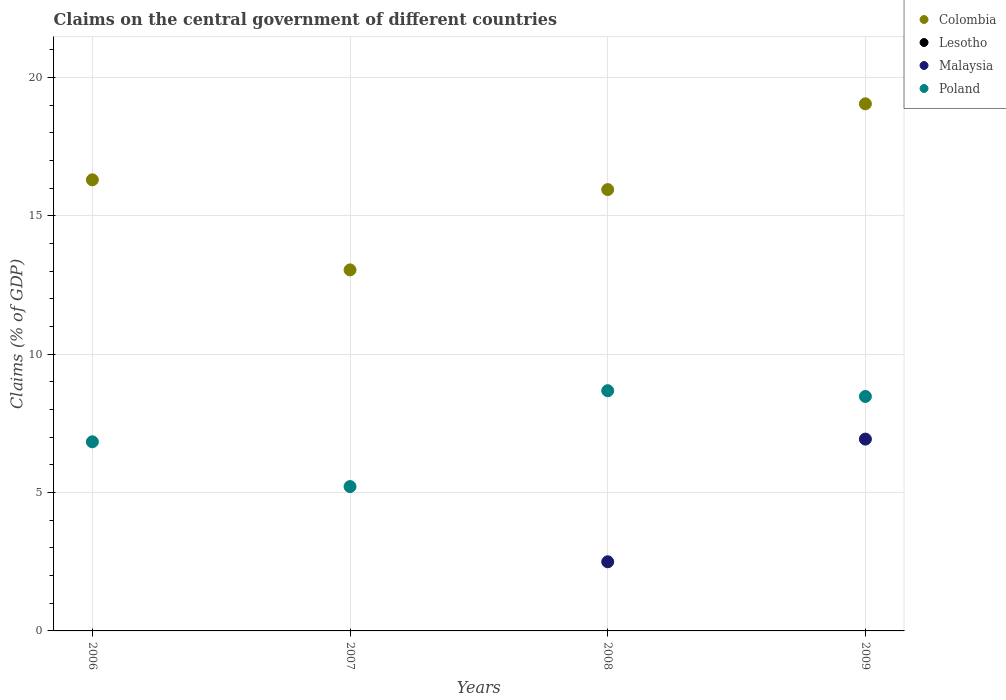What is the percentage of GDP claimed on the central government in Colombia in 2009?
Ensure brevity in your answer.  19.05. Across all years, what is the maximum percentage of GDP claimed on the central government in Poland?
Provide a succinct answer. 8.68. Across all years, what is the minimum percentage of GDP claimed on the central government in Colombia?
Give a very brief answer. 13.04. What is the total percentage of GDP claimed on the central government in Poland in the graph?
Make the answer very short. 29.2. What is the difference between the percentage of GDP claimed on the central government in Malaysia in 2008 and that in 2009?
Your response must be concise. -4.43. What is the difference between the percentage of GDP claimed on the central government in Lesotho in 2006 and the percentage of GDP claimed on the central government in Colombia in 2009?
Ensure brevity in your answer.  -19.05. What is the average percentage of GDP claimed on the central government in Poland per year?
Provide a succinct answer. 7.3. In the year 2008, what is the difference between the percentage of GDP claimed on the central government in Colombia and percentage of GDP claimed on the central government in Poland?
Keep it short and to the point. 7.27. What is the ratio of the percentage of GDP claimed on the central government in Poland in 2006 to that in 2009?
Offer a very short reply. 0.81. Is the percentage of GDP claimed on the central government in Colombia in 2007 less than that in 2009?
Your response must be concise. Yes. Is the difference between the percentage of GDP claimed on the central government in Colombia in 2006 and 2009 greater than the difference between the percentage of GDP claimed on the central government in Poland in 2006 and 2009?
Keep it short and to the point. No. What is the difference between the highest and the second highest percentage of GDP claimed on the central government in Poland?
Offer a very short reply. 0.21. What is the difference between the highest and the lowest percentage of GDP claimed on the central government in Poland?
Make the answer very short. 3.46. Is it the case that in every year, the sum of the percentage of GDP claimed on the central government in Colombia and percentage of GDP claimed on the central government in Lesotho  is greater than the percentage of GDP claimed on the central government in Poland?
Make the answer very short. Yes. Is the percentage of GDP claimed on the central government in Malaysia strictly less than the percentage of GDP claimed on the central government in Colombia over the years?
Ensure brevity in your answer.  Yes. How many years are there in the graph?
Your answer should be very brief. 4. Are the values on the major ticks of Y-axis written in scientific E-notation?
Your response must be concise. No. Does the graph contain any zero values?
Make the answer very short. Yes. Does the graph contain grids?
Give a very brief answer. Yes. How many legend labels are there?
Your answer should be very brief. 4. What is the title of the graph?
Your response must be concise. Claims on the central government of different countries. Does "St. Lucia" appear as one of the legend labels in the graph?
Give a very brief answer. No. What is the label or title of the Y-axis?
Ensure brevity in your answer.  Claims (% of GDP). What is the Claims (% of GDP) in Colombia in 2006?
Give a very brief answer. 16.3. What is the Claims (% of GDP) of Malaysia in 2006?
Give a very brief answer. 0. What is the Claims (% of GDP) in Poland in 2006?
Offer a terse response. 6.83. What is the Claims (% of GDP) in Colombia in 2007?
Keep it short and to the point. 13.04. What is the Claims (% of GDP) in Malaysia in 2007?
Make the answer very short. 0. What is the Claims (% of GDP) of Poland in 2007?
Your answer should be very brief. 5.22. What is the Claims (% of GDP) of Colombia in 2008?
Offer a terse response. 15.95. What is the Claims (% of GDP) of Lesotho in 2008?
Your answer should be very brief. 0. What is the Claims (% of GDP) of Malaysia in 2008?
Ensure brevity in your answer.  2.5. What is the Claims (% of GDP) in Poland in 2008?
Offer a terse response. 8.68. What is the Claims (% of GDP) of Colombia in 2009?
Keep it short and to the point. 19.05. What is the Claims (% of GDP) of Malaysia in 2009?
Offer a very short reply. 6.93. What is the Claims (% of GDP) of Poland in 2009?
Your response must be concise. 8.47. Across all years, what is the maximum Claims (% of GDP) in Colombia?
Your response must be concise. 19.05. Across all years, what is the maximum Claims (% of GDP) of Malaysia?
Give a very brief answer. 6.93. Across all years, what is the maximum Claims (% of GDP) of Poland?
Keep it short and to the point. 8.68. Across all years, what is the minimum Claims (% of GDP) of Colombia?
Keep it short and to the point. 13.04. Across all years, what is the minimum Claims (% of GDP) of Poland?
Ensure brevity in your answer.  5.22. What is the total Claims (% of GDP) of Colombia in the graph?
Provide a short and direct response. 64.33. What is the total Claims (% of GDP) in Malaysia in the graph?
Make the answer very short. 9.43. What is the total Claims (% of GDP) of Poland in the graph?
Offer a terse response. 29.2. What is the difference between the Claims (% of GDP) in Colombia in 2006 and that in 2007?
Offer a very short reply. 3.25. What is the difference between the Claims (% of GDP) of Poland in 2006 and that in 2007?
Keep it short and to the point. 1.62. What is the difference between the Claims (% of GDP) in Colombia in 2006 and that in 2008?
Ensure brevity in your answer.  0.35. What is the difference between the Claims (% of GDP) in Poland in 2006 and that in 2008?
Your answer should be very brief. -1.85. What is the difference between the Claims (% of GDP) in Colombia in 2006 and that in 2009?
Your answer should be very brief. -2.75. What is the difference between the Claims (% of GDP) of Poland in 2006 and that in 2009?
Ensure brevity in your answer.  -1.64. What is the difference between the Claims (% of GDP) in Colombia in 2007 and that in 2008?
Give a very brief answer. -2.9. What is the difference between the Claims (% of GDP) in Poland in 2007 and that in 2008?
Ensure brevity in your answer.  -3.46. What is the difference between the Claims (% of GDP) of Colombia in 2007 and that in 2009?
Offer a terse response. -6. What is the difference between the Claims (% of GDP) in Poland in 2007 and that in 2009?
Offer a terse response. -3.26. What is the difference between the Claims (% of GDP) in Colombia in 2008 and that in 2009?
Keep it short and to the point. -3.1. What is the difference between the Claims (% of GDP) of Malaysia in 2008 and that in 2009?
Make the answer very short. -4.43. What is the difference between the Claims (% of GDP) in Poland in 2008 and that in 2009?
Your answer should be compact. 0.21. What is the difference between the Claims (% of GDP) of Colombia in 2006 and the Claims (% of GDP) of Poland in 2007?
Offer a very short reply. 11.08. What is the difference between the Claims (% of GDP) in Colombia in 2006 and the Claims (% of GDP) in Malaysia in 2008?
Ensure brevity in your answer.  13.8. What is the difference between the Claims (% of GDP) in Colombia in 2006 and the Claims (% of GDP) in Poland in 2008?
Provide a short and direct response. 7.62. What is the difference between the Claims (% of GDP) of Colombia in 2006 and the Claims (% of GDP) of Malaysia in 2009?
Give a very brief answer. 9.37. What is the difference between the Claims (% of GDP) of Colombia in 2006 and the Claims (% of GDP) of Poland in 2009?
Offer a very short reply. 7.83. What is the difference between the Claims (% of GDP) in Colombia in 2007 and the Claims (% of GDP) in Malaysia in 2008?
Your answer should be very brief. 10.55. What is the difference between the Claims (% of GDP) in Colombia in 2007 and the Claims (% of GDP) in Poland in 2008?
Your answer should be compact. 4.36. What is the difference between the Claims (% of GDP) in Colombia in 2007 and the Claims (% of GDP) in Malaysia in 2009?
Your answer should be very brief. 6.11. What is the difference between the Claims (% of GDP) in Colombia in 2007 and the Claims (% of GDP) in Poland in 2009?
Your answer should be very brief. 4.57. What is the difference between the Claims (% of GDP) in Colombia in 2008 and the Claims (% of GDP) in Malaysia in 2009?
Give a very brief answer. 9.01. What is the difference between the Claims (% of GDP) of Colombia in 2008 and the Claims (% of GDP) of Poland in 2009?
Provide a short and direct response. 7.47. What is the difference between the Claims (% of GDP) in Malaysia in 2008 and the Claims (% of GDP) in Poland in 2009?
Provide a short and direct response. -5.97. What is the average Claims (% of GDP) in Colombia per year?
Provide a short and direct response. 16.08. What is the average Claims (% of GDP) in Lesotho per year?
Keep it short and to the point. 0. What is the average Claims (% of GDP) in Malaysia per year?
Give a very brief answer. 2.36. What is the average Claims (% of GDP) of Poland per year?
Make the answer very short. 7.3. In the year 2006, what is the difference between the Claims (% of GDP) of Colombia and Claims (% of GDP) of Poland?
Your answer should be very brief. 9.47. In the year 2007, what is the difference between the Claims (% of GDP) in Colombia and Claims (% of GDP) in Poland?
Give a very brief answer. 7.83. In the year 2008, what is the difference between the Claims (% of GDP) of Colombia and Claims (% of GDP) of Malaysia?
Provide a short and direct response. 13.45. In the year 2008, what is the difference between the Claims (% of GDP) in Colombia and Claims (% of GDP) in Poland?
Provide a short and direct response. 7.27. In the year 2008, what is the difference between the Claims (% of GDP) of Malaysia and Claims (% of GDP) of Poland?
Give a very brief answer. -6.18. In the year 2009, what is the difference between the Claims (% of GDP) of Colombia and Claims (% of GDP) of Malaysia?
Your response must be concise. 12.11. In the year 2009, what is the difference between the Claims (% of GDP) of Colombia and Claims (% of GDP) of Poland?
Give a very brief answer. 10.57. In the year 2009, what is the difference between the Claims (% of GDP) in Malaysia and Claims (% of GDP) in Poland?
Offer a very short reply. -1.54. What is the ratio of the Claims (% of GDP) of Colombia in 2006 to that in 2007?
Your answer should be compact. 1.25. What is the ratio of the Claims (% of GDP) in Poland in 2006 to that in 2007?
Provide a succinct answer. 1.31. What is the ratio of the Claims (% of GDP) in Colombia in 2006 to that in 2008?
Ensure brevity in your answer.  1.02. What is the ratio of the Claims (% of GDP) of Poland in 2006 to that in 2008?
Provide a short and direct response. 0.79. What is the ratio of the Claims (% of GDP) of Colombia in 2006 to that in 2009?
Provide a succinct answer. 0.86. What is the ratio of the Claims (% of GDP) in Poland in 2006 to that in 2009?
Your answer should be very brief. 0.81. What is the ratio of the Claims (% of GDP) in Colombia in 2007 to that in 2008?
Offer a terse response. 0.82. What is the ratio of the Claims (% of GDP) in Poland in 2007 to that in 2008?
Offer a very short reply. 0.6. What is the ratio of the Claims (% of GDP) in Colombia in 2007 to that in 2009?
Your answer should be very brief. 0.68. What is the ratio of the Claims (% of GDP) in Poland in 2007 to that in 2009?
Offer a very short reply. 0.62. What is the ratio of the Claims (% of GDP) of Colombia in 2008 to that in 2009?
Give a very brief answer. 0.84. What is the ratio of the Claims (% of GDP) in Malaysia in 2008 to that in 2009?
Your response must be concise. 0.36. What is the ratio of the Claims (% of GDP) in Poland in 2008 to that in 2009?
Provide a succinct answer. 1.02. What is the difference between the highest and the second highest Claims (% of GDP) in Colombia?
Make the answer very short. 2.75. What is the difference between the highest and the second highest Claims (% of GDP) in Poland?
Give a very brief answer. 0.21. What is the difference between the highest and the lowest Claims (% of GDP) in Colombia?
Offer a terse response. 6. What is the difference between the highest and the lowest Claims (% of GDP) in Malaysia?
Offer a terse response. 6.93. What is the difference between the highest and the lowest Claims (% of GDP) of Poland?
Give a very brief answer. 3.46. 